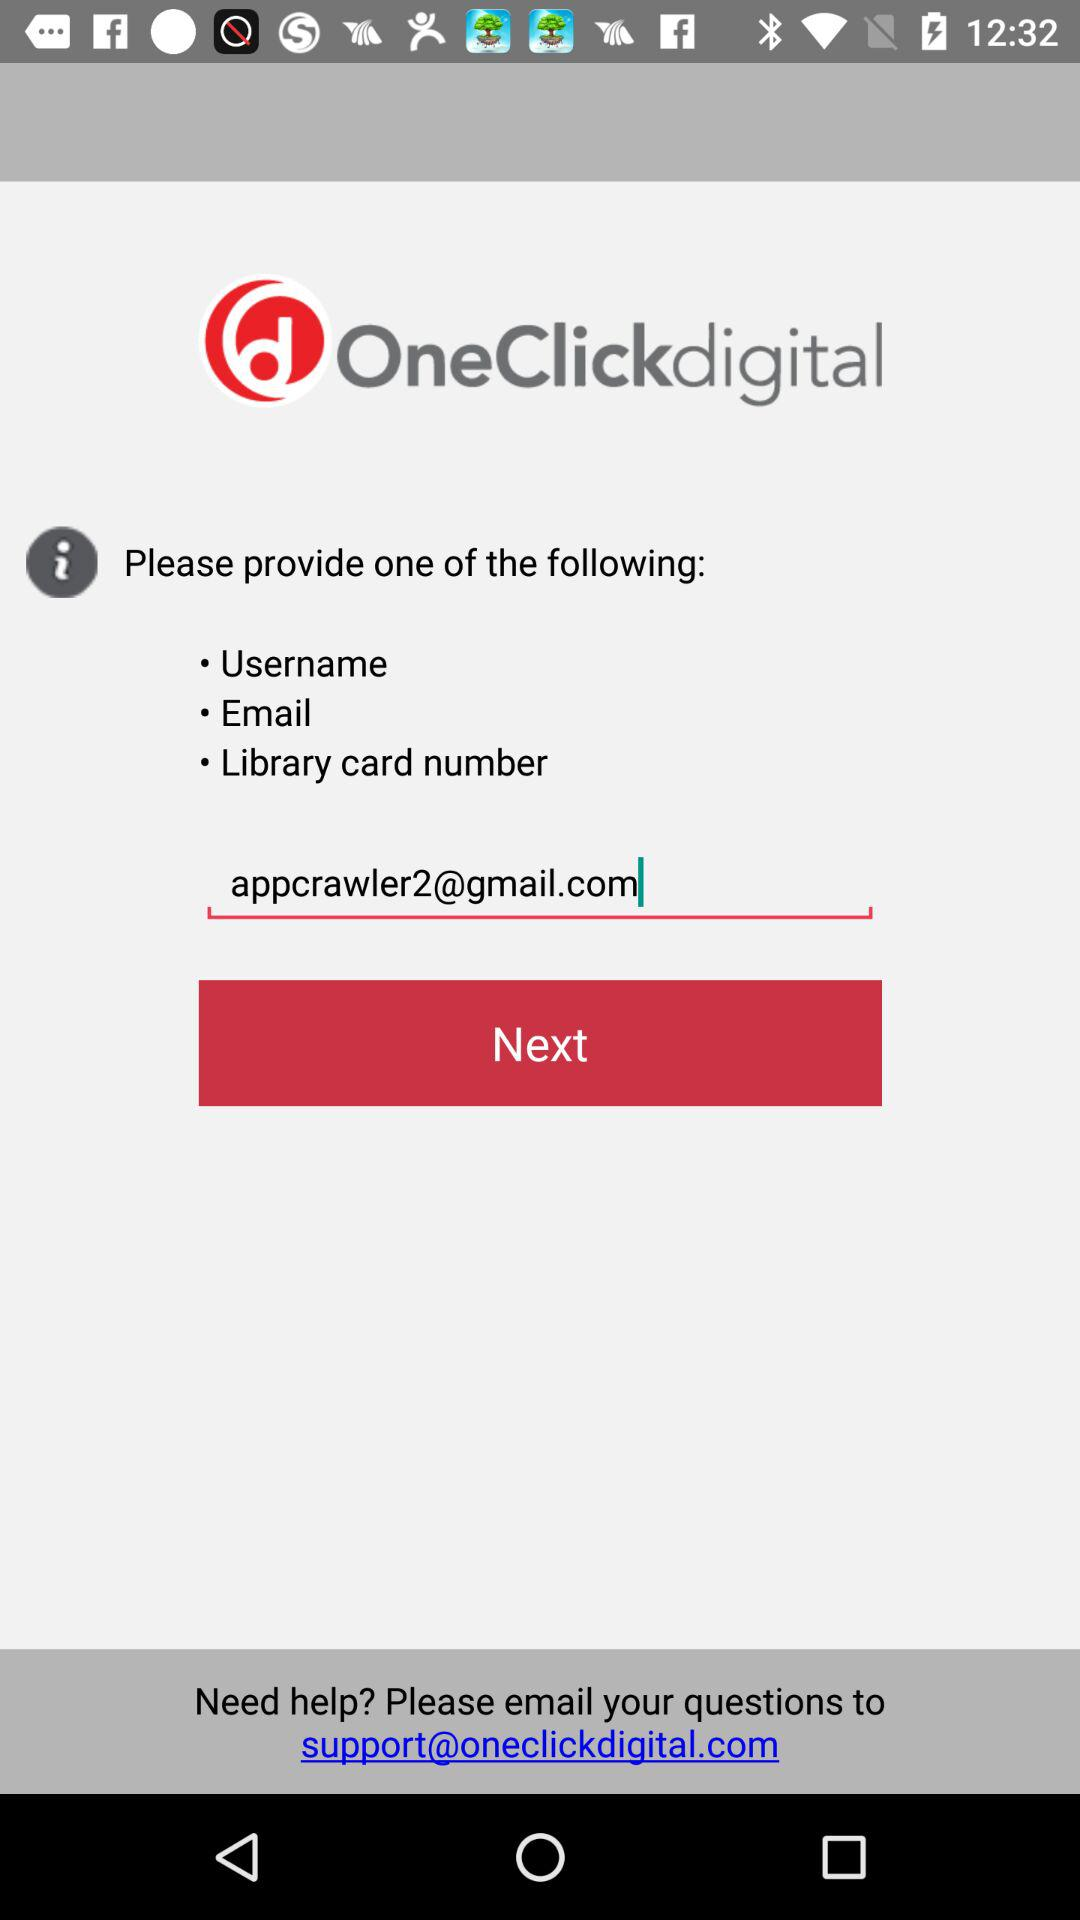What is the given email address? The given email addresses are appcrawler2@gmail.com and support@oneclickdigital.com. 